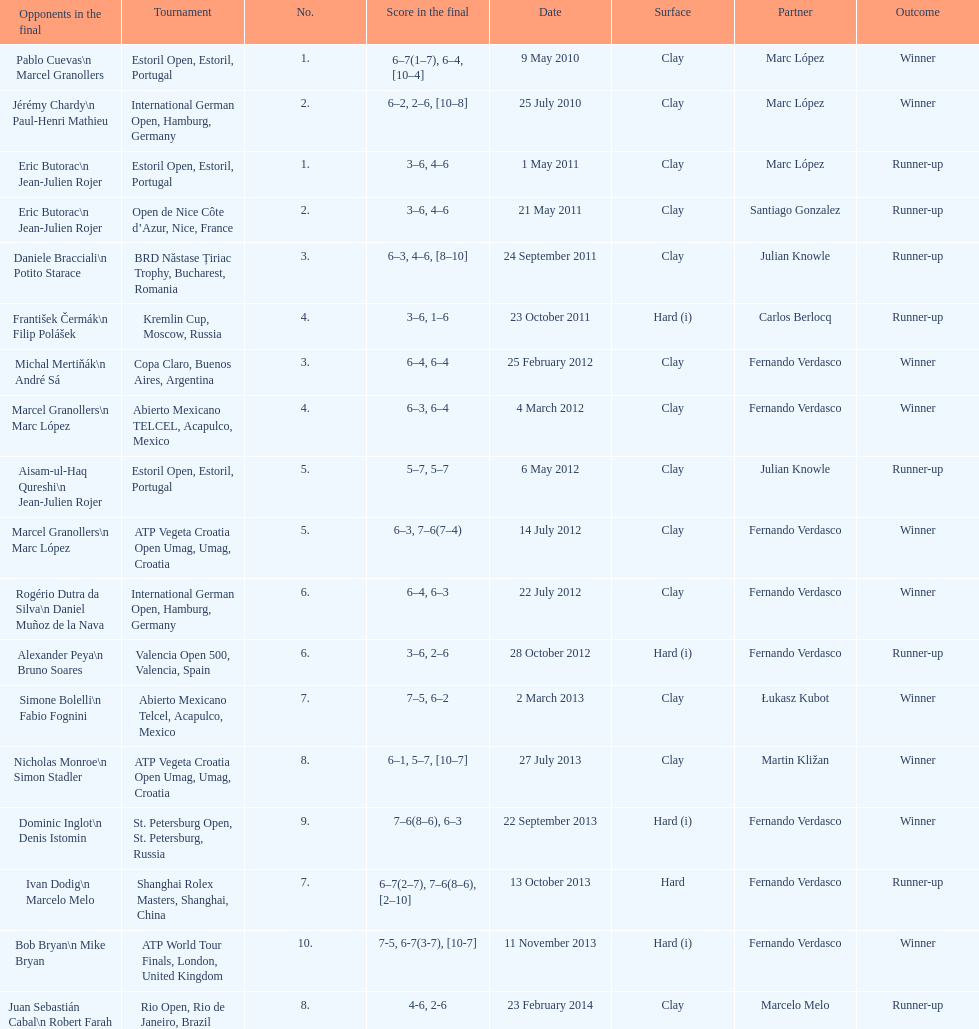How many tournaments has this player won in his career so far? 10. 